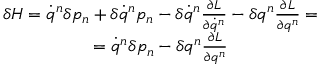<formula> <loc_0><loc_0><loc_500><loc_500>\begin{array} { c } { \delta H = \dot { q } ^ { n } \delta p _ { n } + \delta \dot { q } ^ { n } p _ { n } - \delta \dot { q } ^ { n } \frac { \partial L } { \partial \dot { q } ^ { n } } - \delta q ^ { n } \frac { \partial L } { \partial q ^ { n } } = } \\ { = \dot { q } ^ { n } \delta p _ { n } - \delta q ^ { n } \frac { \partial L } { \partial q ^ { n } } } \end{array}</formula> 